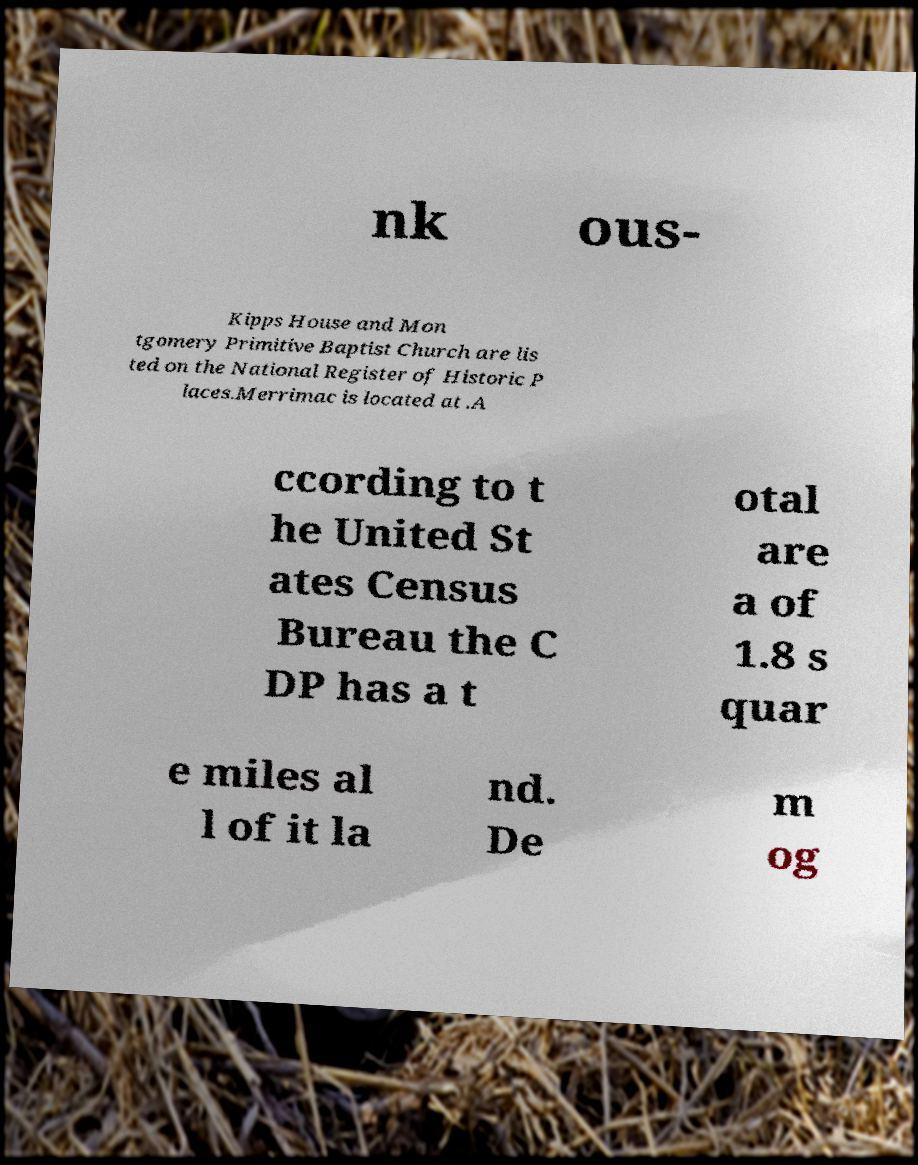What messages or text are displayed in this image? I need them in a readable, typed format. nk ous- Kipps House and Mon tgomery Primitive Baptist Church are lis ted on the National Register of Historic P laces.Merrimac is located at .A ccording to t he United St ates Census Bureau the C DP has a t otal are a of 1.8 s quar e miles al l of it la nd. De m og 